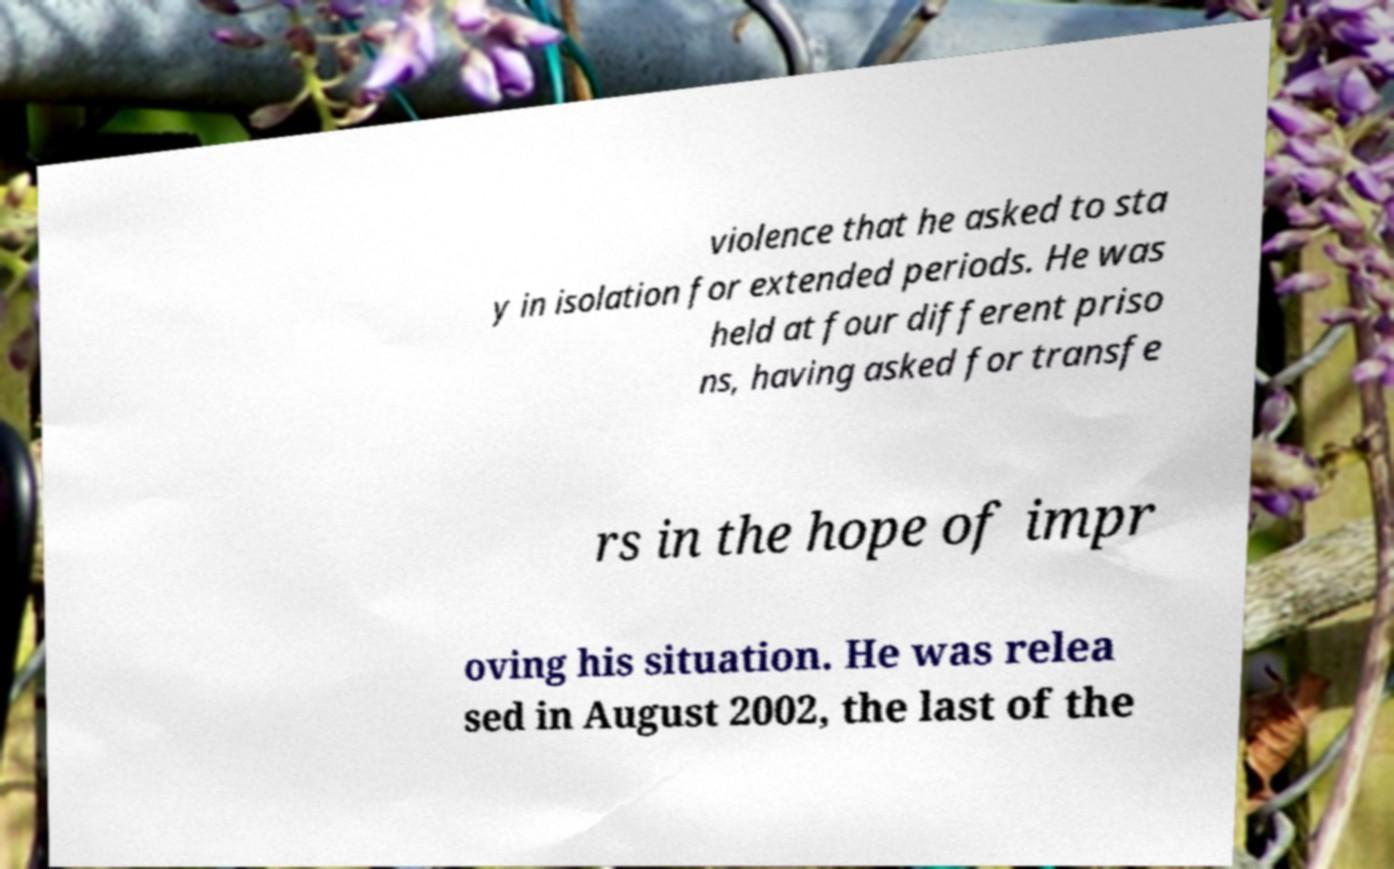There's text embedded in this image that I need extracted. Can you transcribe it verbatim? violence that he asked to sta y in isolation for extended periods. He was held at four different priso ns, having asked for transfe rs in the hope of impr oving his situation. He was relea sed in August 2002, the last of the 